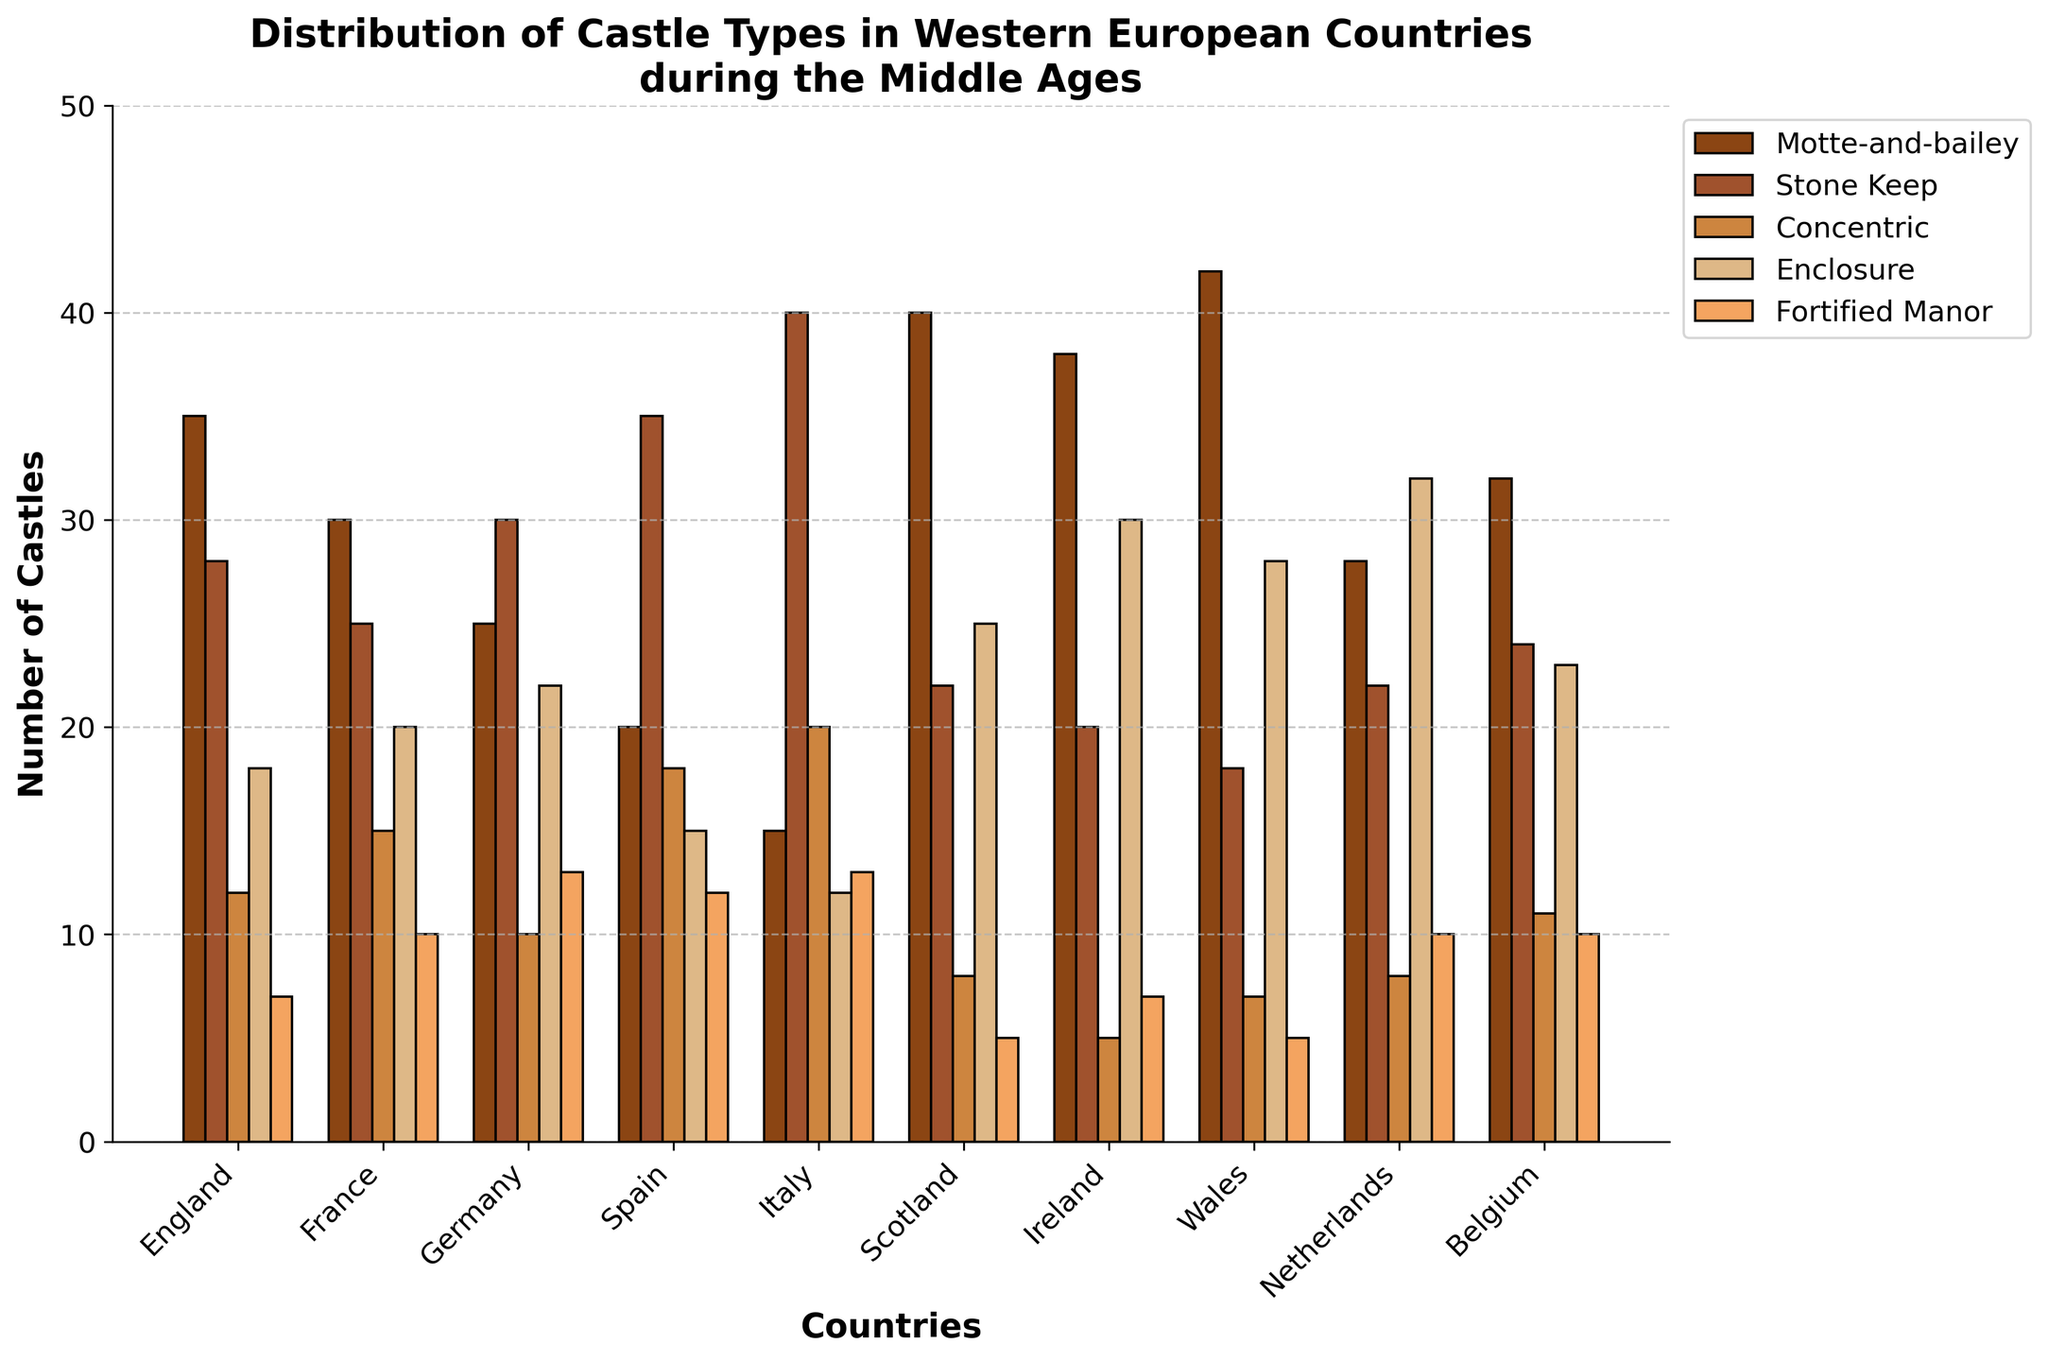What country has the highest number of Motte-and-bailey castles? From the bar chart, Wales has the tallest bar for Motte-and-bailey castles.
Answer: Wales Which country has the fewest Concentric castles? By observing the bars, Ireland has the shortest bar for Concentric castles.
Answer: Ireland Compare the number of Stone Keep castles in Italy and Spain. Which country has more? Italy has the tallest bar for Stone Keep castles compared to Spain.
Answer: Italy How many more Enclosure castles does Ireland have compared to Spain? The bar height for Enclosure castles in Ireland is 30, while in Spain, it is 15. The difference is 30 - 15 = 15.
Answer: 15 Which castle type is the most common in Scotland? The tallest bar in Scotland corresponds to Motte-and-bailey castles.
Answer: Motte-and-bailey Sum the number of Fortified Manor castles in Germany and Italy. Germany has 13 Fortified Manor castles, and Italy has 13. Summing them gives 13 + 13 = 26.
Answer: 26 What is the average number of Stone Keep castles in England, France, and Belgium? The values are 28 (England), 25 (France), and 24 (Belgium). The sum is 28 + 25 + 24 = 77. The average is 77 / 3 ≈ 25.67.
Answer: 25.67 Determine whether the sum of Enclosure castles in Wales and Scotland exceeds 50. Wales has 28 and Scotland has 25 Enclosure castles. The sum is 28 + 25 = 53, which exceeds 50.
Answer: Yes By how much do the total number of castle types in England exceed those in Belgium? Sum the castle types for England (35 + 28 + 12 + 18 + 7 = 100) and Belgium (32 + 24 + 11 + 23 + 10 = 100). They are equal, so the excess is 0.
Answer: 0 Identify the country with the lowest total number of castles. Sum the total castles by country and compare. Italy has the least with (15 + 40 + 20 + 12 + 13 = 100).
Answer: Italy 